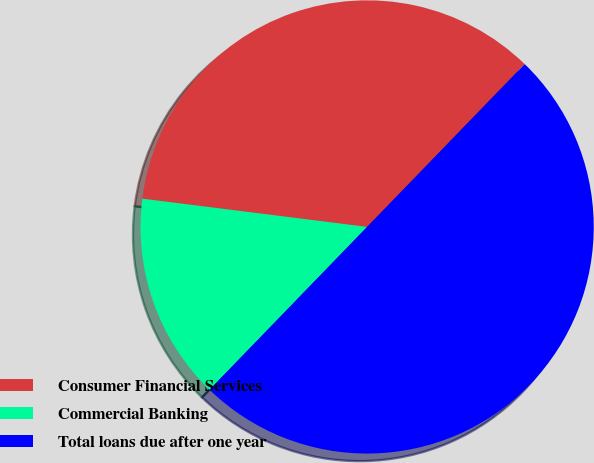Convert chart. <chart><loc_0><loc_0><loc_500><loc_500><pie_chart><fcel>Consumer Financial Services<fcel>Commercial Banking<fcel>Total loans due after one year<nl><fcel>35.25%<fcel>14.75%<fcel>50.0%<nl></chart> 